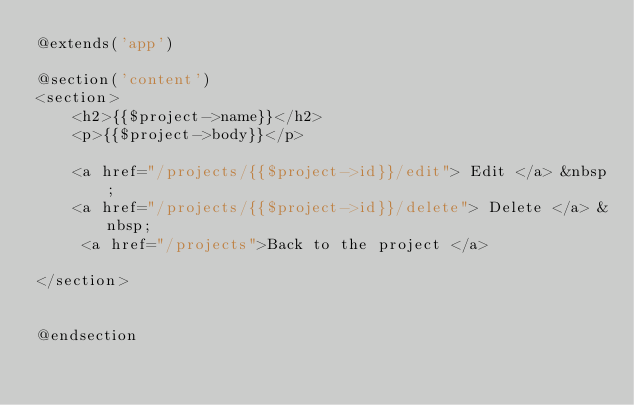Convert code to text. <code><loc_0><loc_0><loc_500><loc_500><_PHP_>@extends('app')

@section('content')
<section>
    <h2>{{$project->name}}</h2>
    <p>{{$project->body}}</p>

    <a href="/projects/{{$project->id}}/edit"> Edit </a> &nbsp;
    <a href="/projects/{{$project->id}}/delete"> Delete </a> &nbsp;
     <a href="/projects">Back to the project </a>
   
</section>


@endsection</code> 